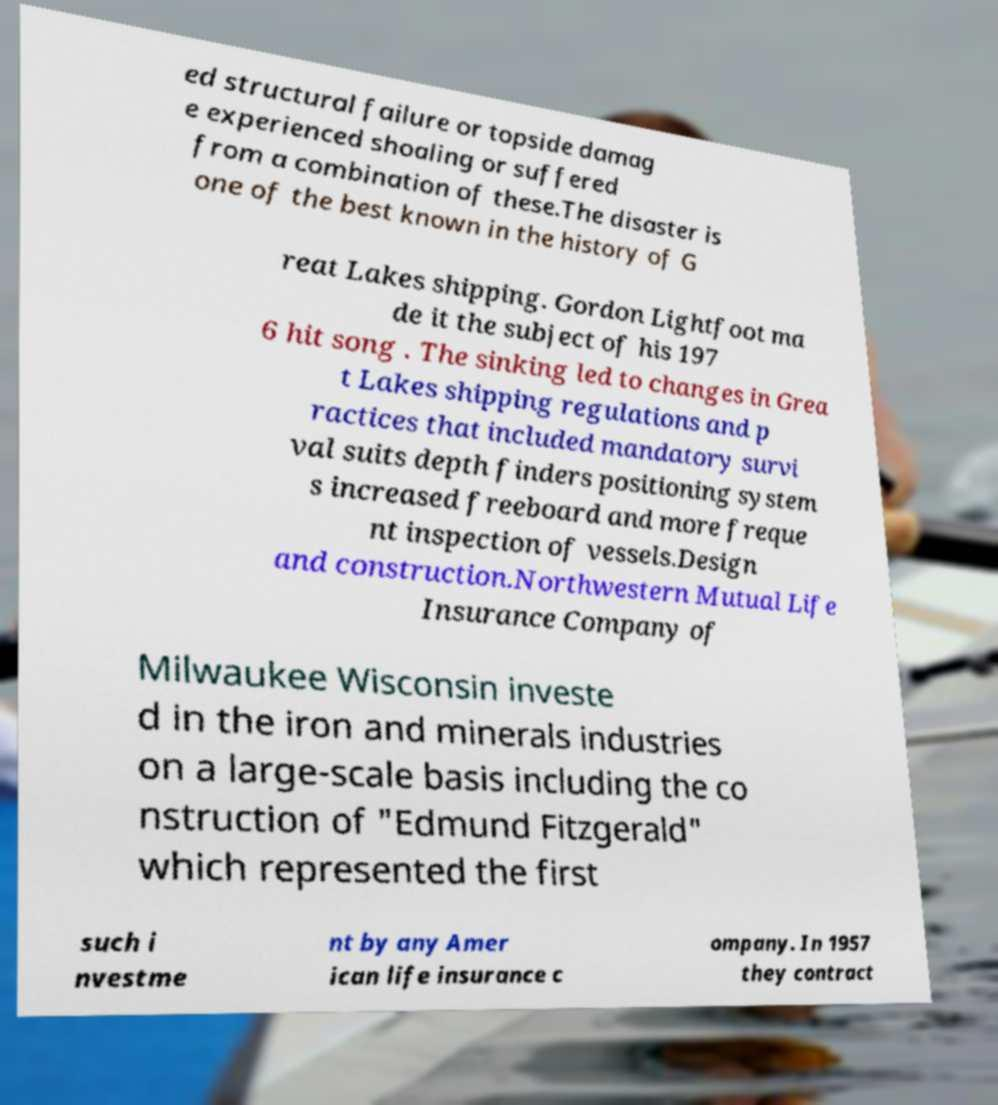What messages or text are displayed in this image? I need them in a readable, typed format. ed structural failure or topside damag e experienced shoaling or suffered from a combination of these.The disaster is one of the best known in the history of G reat Lakes shipping. Gordon Lightfoot ma de it the subject of his 197 6 hit song . The sinking led to changes in Grea t Lakes shipping regulations and p ractices that included mandatory survi val suits depth finders positioning system s increased freeboard and more freque nt inspection of vessels.Design and construction.Northwestern Mutual Life Insurance Company of Milwaukee Wisconsin investe d in the iron and minerals industries on a large-scale basis including the co nstruction of "Edmund Fitzgerald" which represented the first such i nvestme nt by any Amer ican life insurance c ompany. In 1957 they contract 